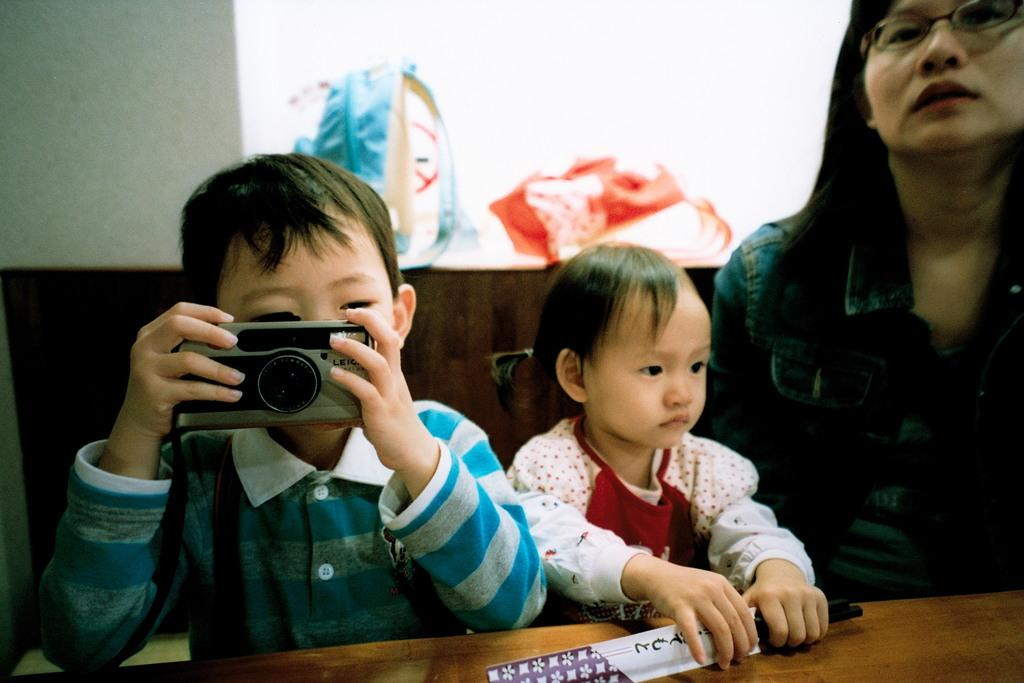How many people are in the image? There are three people in the image. What is one person doing in the image? One person is holding a camera. What object is in front of the people? There is a table in front of the people. Can you tell me how many snails are crawling on the table in the image? There are no snails present in the image; the table is empty except for the people and the camera. 